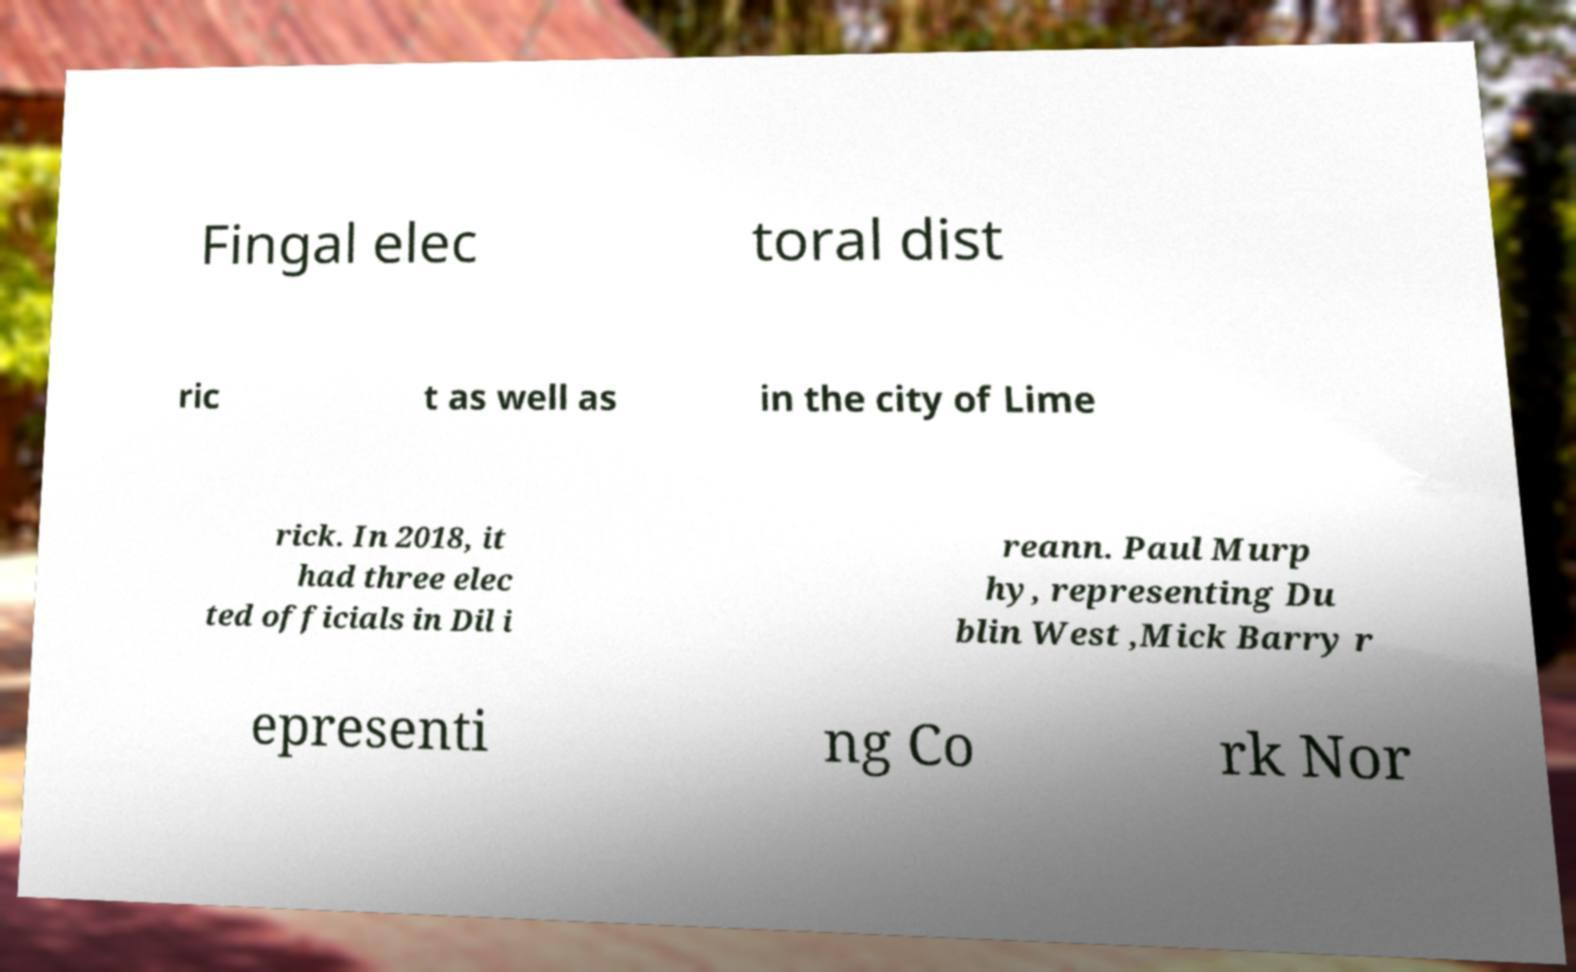What messages or text are displayed in this image? I need them in a readable, typed format. Fingal elec toral dist ric t as well as in the city of Lime rick. In 2018, it had three elec ted officials in Dil i reann. Paul Murp hy, representing Du blin West ,Mick Barry r epresenti ng Co rk Nor 